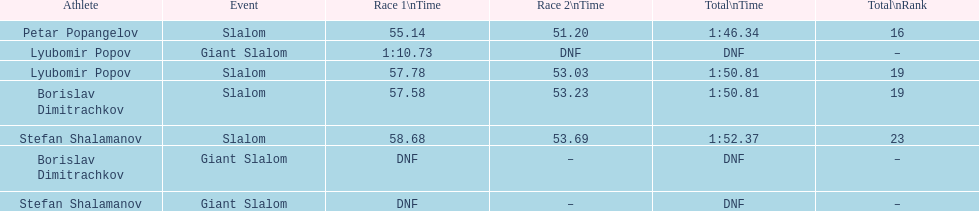What is the number of athletes to finish race one in the giant slalom? 1. Could you parse the entire table as a dict? {'header': ['Athlete', 'Event', 'Race 1\\nTime', 'Race 2\\nTime', 'Total\\nTime', 'Total\\nRank'], 'rows': [['Petar Popangelov', 'Slalom', '55.14', '51.20', '1:46.34', '16'], ['Lyubomir Popov', 'Giant Slalom', '1:10.73', 'DNF', 'DNF', '–'], ['Lyubomir Popov', 'Slalom', '57.78', '53.03', '1:50.81', '19'], ['Borislav Dimitrachkov', 'Slalom', '57.58', '53.23', '1:50.81', '19'], ['Stefan Shalamanov', 'Slalom', '58.68', '53.69', '1:52.37', '23'], ['Borislav Dimitrachkov', 'Giant Slalom', 'DNF', '–', 'DNF', '–'], ['Stefan Shalamanov', 'Giant Slalom', 'DNF', '–', 'DNF', '–']]} 